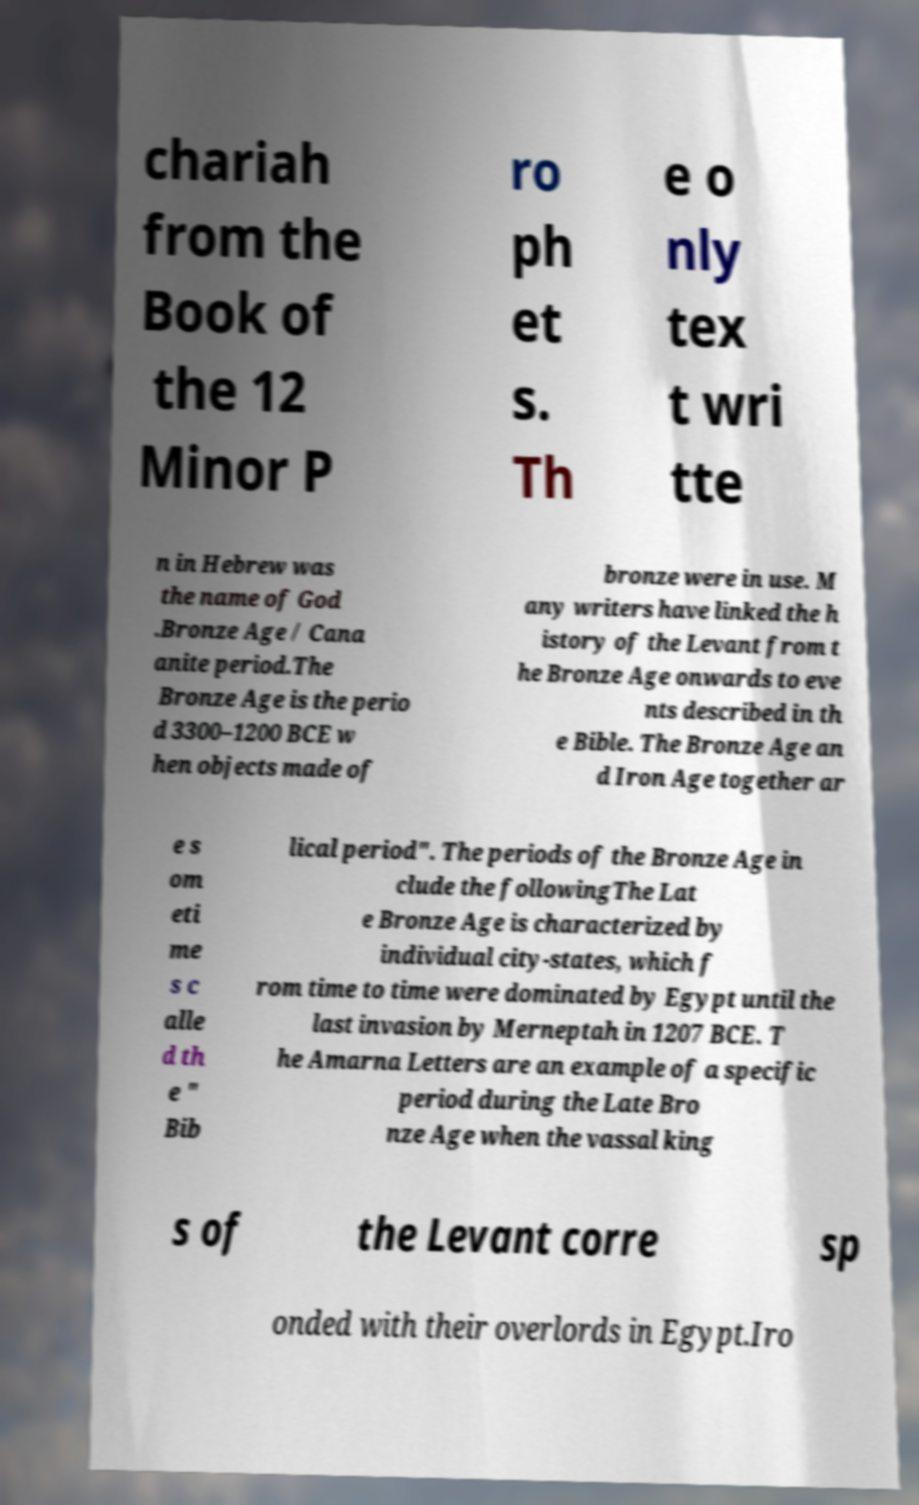Please read and relay the text visible in this image. What does it say? chariah from the Book of the 12 Minor P ro ph et s. Th e o nly tex t wri tte n in Hebrew was the name of God .Bronze Age / Cana anite period.The Bronze Age is the perio d 3300–1200 BCE w hen objects made of bronze were in use. M any writers have linked the h istory of the Levant from t he Bronze Age onwards to eve nts described in th e Bible. The Bronze Age an d Iron Age together ar e s om eti me s c alle d th e " Bib lical period". The periods of the Bronze Age in clude the followingThe Lat e Bronze Age is characterized by individual city-states, which f rom time to time were dominated by Egypt until the last invasion by Merneptah in 1207 BCE. T he Amarna Letters are an example of a specific period during the Late Bro nze Age when the vassal king s of the Levant corre sp onded with their overlords in Egypt.Iro 